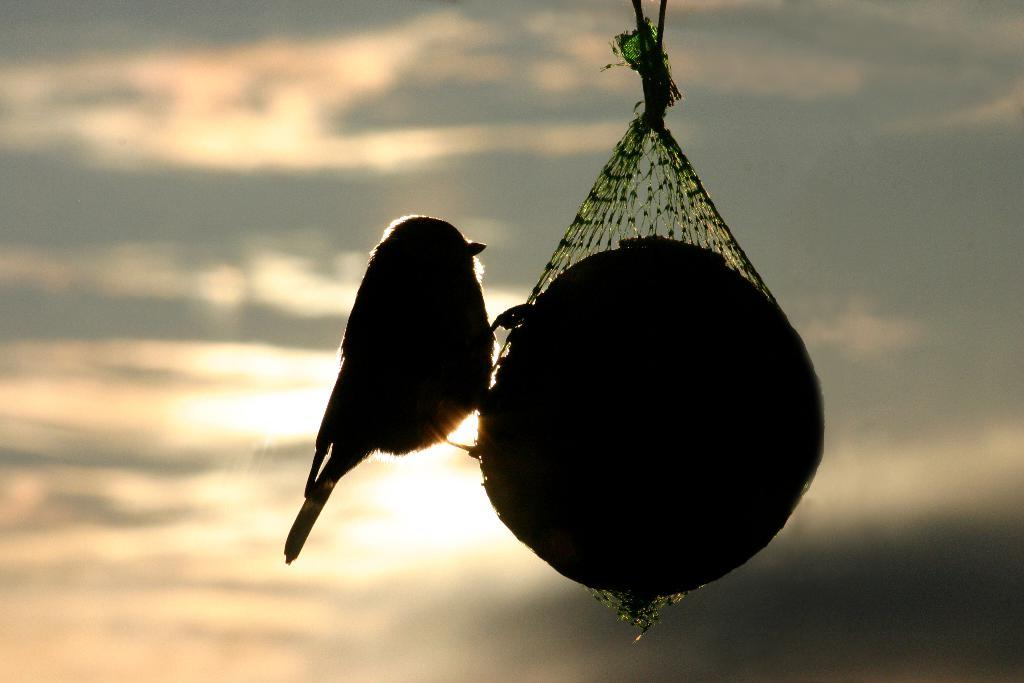What type of animal is in the image? There is a bird in the image. What is the bird standing on? The bird is on a ball in the image. How is the ball covered? The ball is covered with a net. How is the net secured? The net is tied with a rope. What can be seen in the background of the image? The sky is visible in the image. What is the weather like in the image? The sky looks cloudy in the image. Where is the bat located in the image? There is no bat present in the image; it features a bird on a ball. Can you tell me how many books are on the shelf in the image? There is no shelf present in the image. 